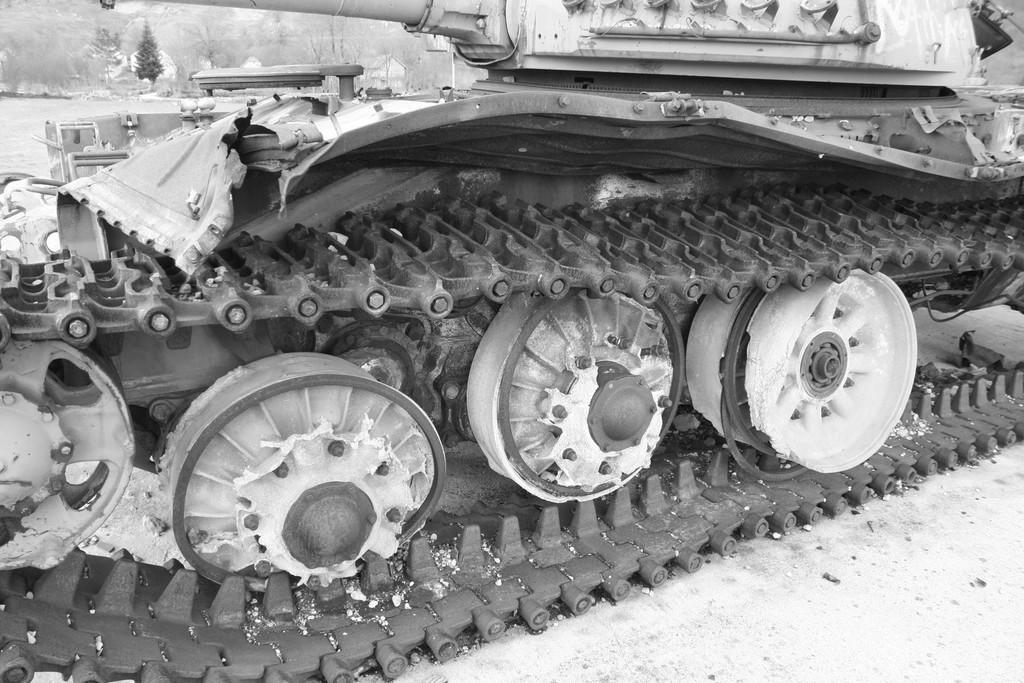What is the main subject of the image? There is a vehicle in the image. What type of vehicle is it? The vehicle is used in deserts. Can you see any cobwebs in the image? There is no mention of cobwebs in the provided facts, and therefore we cannot determine if any are present in the image. Is there a tiger in the image? There is no mention of a tiger in the provided facts, and therefore we cannot determine if one is present in the image. 